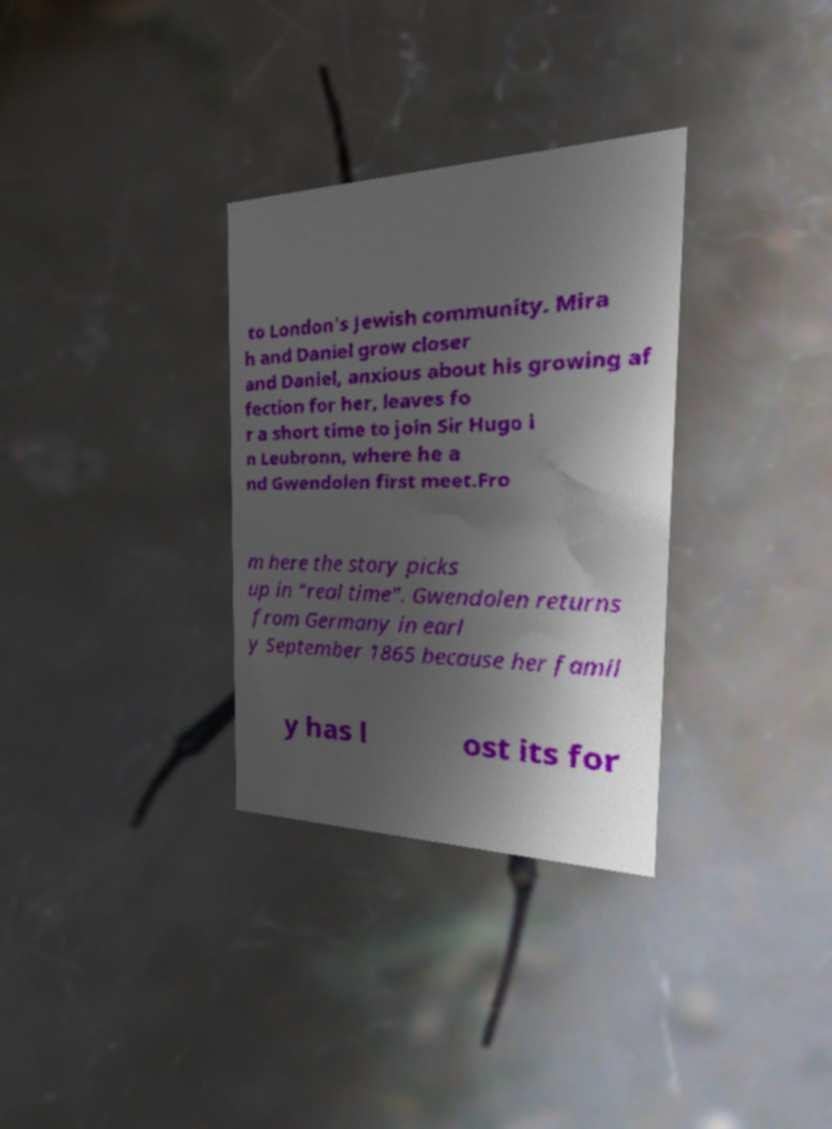For documentation purposes, I need the text within this image transcribed. Could you provide that? to London's Jewish community. Mira h and Daniel grow closer and Daniel, anxious about his growing af fection for her, leaves fo r a short time to join Sir Hugo i n Leubronn, where he a nd Gwendolen first meet.Fro m here the story picks up in "real time". Gwendolen returns from Germany in earl y September 1865 because her famil y has l ost its for 